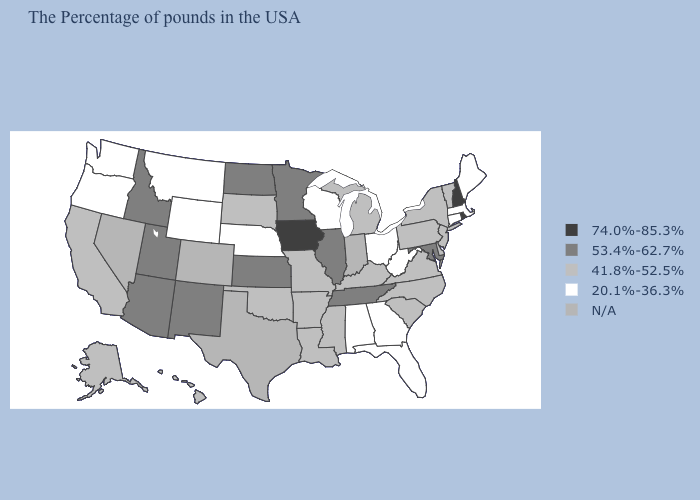Among the states that border New York , which have the lowest value?
Quick response, please. Massachusetts, Connecticut. Does Maine have the lowest value in the USA?
Give a very brief answer. Yes. Name the states that have a value in the range 74.0%-85.3%?
Give a very brief answer. Rhode Island, New Hampshire, Iowa. What is the value of Ohio?
Be succinct. 20.1%-36.3%. Name the states that have a value in the range 20.1%-36.3%?
Write a very short answer. Maine, Massachusetts, Connecticut, West Virginia, Ohio, Florida, Georgia, Alabama, Wisconsin, Nebraska, Wyoming, Montana, Washington, Oregon. Is the legend a continuous bar?
Give a very brief answer. No. Name the states that have a value in the range 41.8%-52.5%?
Keep it brief. Vermont, New York, New Jersey, Delaware, Pennsylvania, Virginia, North Carolina, South Carolina, Michigan, Kentucky, Mississippi, Louisiana, Missouri, Arkansas, Oklahoma, South Dakota, California, Alaska, Hawaii. Which states have the lowest value in the MidWest?
Write a very short answer. Ohio, Wisconsin, Nebraska. Which states have the lowest value in the USA?
Write a very short answer. Maine, Massachusetts, Connecticut, West Virginia, Ohio, Florida, Georgia, Alabama, Wisconsin, Nebraska, Wyoming, Montana, Washington, Oregon. Which states have the lowest value in the West?
Quick response, please. Wyoming, Montana, Washington, Oregon. Does the map have missing data?
Quick response, please. Yes. What is the value of Florida?
Keep it brief. 20.1%-36.3%. Among the states that border Florida , which have the lowest value?
Give a very brief answer. Georgia, Alabama. Name the states that have a value in the range 20.1%-36.3%?
Answer briefly. Maine, Massachusetts, Connecticut, West Virginia, Ohio, Florida, Georgia, Alabama, Wisconsin, Nebraska, Wyoming, Montana, Washington, Oregon. 